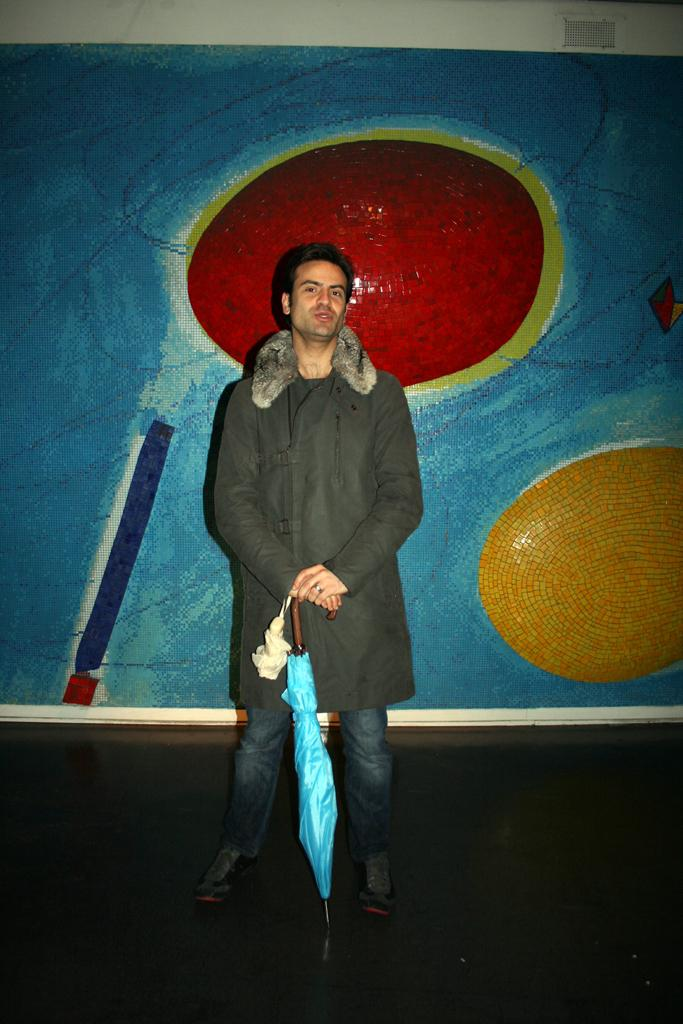Who is present in the image? There is a man in the image. What is the man doing in the image? The man is standing in the image. What object is the man holding in the image? The man is holding a blue color umbrella in the image. What can be seen in the background of the image? There is a painting on the wall in the background of the image. How many boats are visible in the image? There are no boats present in the image. Can you describe the snow in the image? There is no snow present in the image. 